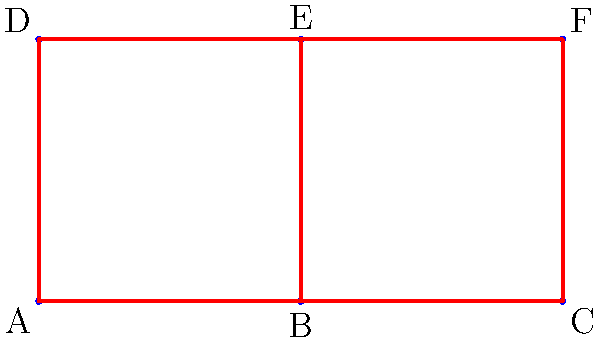Consider the military formation pattern shown in the diagram. What is the order of the symmetry group for this formation, assuming all possible rotations and reflections that preserve the structure? To determine the order of the symmetry group, we need to count all the symmetry operations that leave the formation unchanged:

1. Rotations:
   - Identity (0° rotation)
   - 180° rotation around the center

2. Reflections:
   - Horizontal reflection (across the line between B and E)
   - Vertical reflection (across the line between A-D and C-F)
   - Diagonal reflection (across the line A-F)
   - Diagonal reflection (across the line C-D)

Let's count these symmetries:
- 2 rotations (including identity)
- 4 reflections

The total number of symmetry operations is 2 + 4 = 6.

In group theory, the order of a group is the number of elements in the group. Since each symmetry operation corresponds to a group element, the order of the symmetry group is equal to the number of symmetry operations.
Answer: 6 